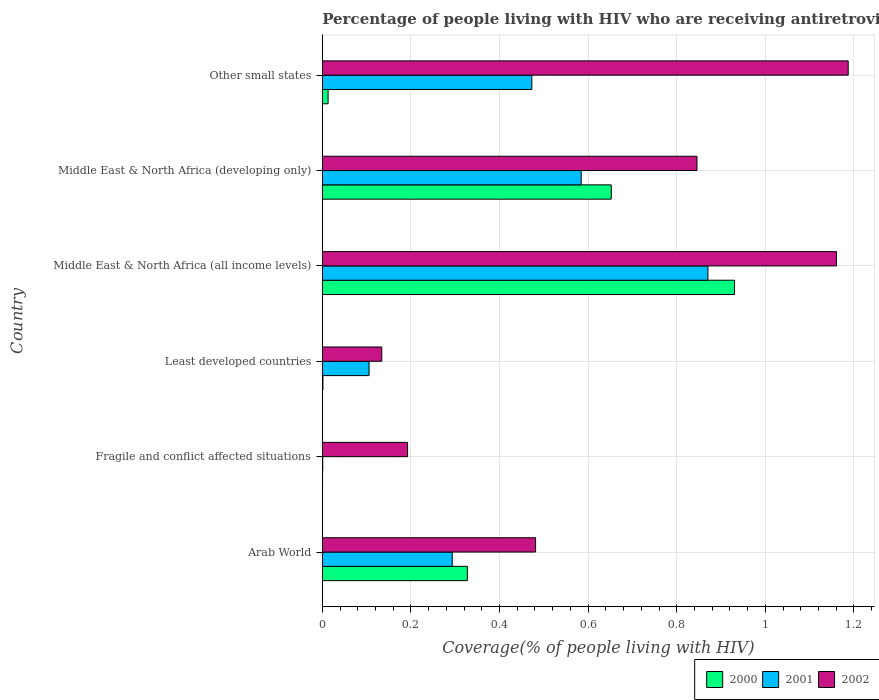How many different coloured bars are there?
Keep it short and to the point. 3. Are the number of bars per tick equal to the number of legend labels?
Your response must be concise. Yes. How many bars are there on the 1st tick from the top?
Keep it short and to the point. 3. What is the label of the 1st group of bars from the top?
Make the answer very short. Other small states. What is the percentage of the HIV infected people who are receiving antiretroviral therapy in 2000 in Middle East & North Africa (developing only)?
Your response must be concise. 0.65. Across all countries, what is the maximum percentage of the HIV infected people who are receiving antiretroviral therapy in 2001?
Provide a short and direct response. 0.87. Across all countries, what is the minimum percentage of the HIV infected people who are receiving antiretroviral therapy in 2002?
Your answer should be compact. 0.13. In which country was the percentage of the HIV infected people who are receiving antiretroviral therapy in 2002 maximum?
Provide a short and direct response. Other small states. In which country was the percentage of the HIV infected people who are receiving antiretroviral therapy in 2000 minimum?
Provide a succinct answer. Fragile and conflict affected situations. What is the total percentage of the HIV infected people who are receiving antiretroviral therapy in 2000 in the graph?
Your answer should be very brief. 1.92. What is the difference between the percentage of the HIV infected people who are receiving antiretroviral therapy in 2000 in Arab World and that in Other small states?
Give a very brief answer. 0.31. What is the difference between the percentage of the HIV infected people who are receiving antiretroviral therapy in 2001 in Fragile and conflict affected situations and the percentage of the HIV infected people who are receiving antiretroviral therapy in 2002 in Least developed countries?
Ensure brevity in your answer.  -0.13. What is the average percentage of the HIV infected people who are receiving antiretroviral therapy in 2002 per country?
Keep it short and to the point. 0.67. What is the difference between the percentage of the HIV infected people who are receiving antiretroviral therapy in 2001 and percentage of the HIV infected people who are receiving antiretroviral therapy in 2000 in Middle East & North Africa (developing only)?
Give a very brief answer. -0.07. In how many countries, is the percentage of the HIV infected people who are receiving antiretroviral therapy in 2000 greater than 0.12 %?
Offer a very short reply. 3. What is the ratio of the percentage of the HIV infected people who are receiving antiretroviral therapy in 2002 in Arab World to that in Middle East & North Africa (all income levels)?
Keep it short and to the point. 0.41. What is the difference between the highest and the second highest percentage of the HIV infected people who are receiving antiretroviral therapy in 2001?
Provide a succinct answer. 0.29. What is the difference between the highest and the lowest percentage of the HIV infected people who are receiving antiretroviral therapy in 2001?
Your answer should be compact. 0.87. Is the sum of the percentage of the HIV infected people who are receiving antiretroviral therapy in 2001 in Arab World and Other small states greater than the maximum percentage of the HIV infected people who are receiving antiretroviral therapy in 2002 across all countries?
Your response must be concise. No. What does the 2nd bar from the top in Fragile and conflict affected situations represents?
Make the answer very short. 2001. What does the 2nd bar from the bottom in Other small states represents?
Provide a succinct answer. 2001. How many bars are there?
Give a very brief answer. 18. Are all the bars in the graph horizontal?
Your answer should be very brief. Yes. How many countries are there in the graph?
Your response must be concise. 6. What is the difference between two consecutive major ticks on the X-axis?
Provide a short and direct response. 0.2. Are the values on the major ticks of X-axis written in scientific E-notation?
Your answer should be very brief. No. Does the graph contain any zero values?
Keep it short and to the point. No. Does the graph contain grids?
Your response must be concise. Yes. Where does the legend appear in the graph?
Ensure brevity in your answer.  Bottom right. What is the title of the graph?
Offer a very short reply. Percentage of people living with HIV who are receiving antiretroviral therapy. Does "1998" appear as one of the legend labels in the graph?
Ensure brevity in your answer.  No. What is the label or title of the X-axis?
Provide a short and direct response. Coverage(% of people living with HIV). What is the Coverage(% of people living with HIV) in 2000 in Arab World?
Ensure brevity in your answer.  0.33. What is the Coverage(% of people living with HIV) of 2001 in Arab World?
Your answer should be very brief. 0.29. What is the Coverage(% of people living with HIV) of 2002 in Arab World?
Make the answer very short. 0.48. What is the Coverage(% of people living with HIV) in 2000 in Fragile and conflict affected situations?
Offer a very short reply. 0. What is the Coverage(% of people living with HIV) in 2001 in Fragile and conflict affected situations?
Give a very brief answer. 0. What is the Coverage(% of people living with HIV) in 2002 in Fragile and conflict affected situations?
Provide a succinct answer. 0.19. What is the Coverage(% of people living with HIV) of 2000 in Least developed countries?
Ensure brevity in your answer.  0. What is the Coverage(% of people living with HIV) of 2001 in Least developed countries?
Provide a succinct answer. 0.11. What is the Coverage(% of people living with HIV) in 2002 in Least developed countries?
Offer a terse response. 0.13. What is the Coverage(% of people living with HIV) in 2000 in Middle East & North Africa (all income levels)?
Provide a short and direct response. 0.93. What is the Coverage(% of people living with HIV) of 2001 in Middle East & North Africa (all income levels)?
Your answer should be compact. 0.87. What is the Coverage(% of people living with HIV) of 2002 in Middle East & North Africa (all income levels)?
Offer a terse response. 1.16. What is the Coverage(% of people living with HIV) in 2000 in Middle East & North Africa (developing only)?
Provide a short and direct response. 0.65. What is the Coverage(% of people living with HIV) in 2001 in Middle East & North Africa (developing only)?
Offer a terse response. 0.58. What is the Coverage(% of people living with HIV) in 2002 in Middle East & North Africa (developing only)?
Your response must be concise. 0.85. What is the Coverage(% of people living with HIV) of 2000 in Other small states?
Your answer should be very brief. 0.01. What is the Coverage(% of people living with HIV) in 2001 in Other small states?
Give a very brief answer. 0.47. What is the Coverage(% of people living with HIV) in 2002 in Other small states?
Provide a short and direct response. 1.19. Across all countries, what is the maximum Coverage(% of people living with HIV) of 2000?
Give a very brief answer. 0.93. Across all countries, what is the maximum Coverage(% of people living with HIV) of 2001?
Make the answer very short. 0.87. Across all countries, what is the maximum Coverage(% of people living with HIV) in 2002?
Your answer should be very brief. 1.19. Across all countries, what is the minimum Coverage(% of people living with HIV) in 2000?
Provide a succinct answer. 0. Across all countries, what is the minimum Coverage(% of people living with HIV) of 2001?
Your response must be concise. 0. Across all countries, what is the minimum Coverage(% of people living with HIV) in 2002?
Provide a succinct answer. 0.13. What is the total Coverage(% of people living with HIV) in 2000 in the graph?
Your response must be concise. 1.92. What is the total Coverage(% of people living with HIV) in 2001 in the graph?
Keep it short and to the point. 2.33. What is the total Coverage(% of people living with HIV) of 2002 in the graph?
Keep it short and to the point. 4. What is the difference between the Coverage(% of people living with HIV) of 2000 in Arab World and that in Fragile and conflict affected situations?
Your answer should be compact. 0.33. What is the difference between the Coverage(% of people living with HIV) in 2001 in Arab World and that in Fragile and conflict affected situations?
Keep it short and to the point. 0.29. What is the difference between the Coverage(% of people living with HIV) of 2002 in Arab World and that in Fragile and conflict affected situations?
Your answer should be very brief. 0.29. What is the difference between the Coverage(% of people living with HIV) of 2000 in Arab World and that in Least developed countries?
Keep it short and to the point. 0.33. What is the difference between the Coverage(% of people living with HIV) of 2001 in Arab World and that in Least developed countries?
Ensure brevity in your answer.  0.19. What is the difference between the Coverage(% of people living with HIV) in 2002 in Arab World and that in Least developed countries?
Your answer should be compact. 0.35. What is the difference between the Coverage(% of people living with HIV) of 2000 in Arab World and that in Middle East & North Africa (all income levels)?
Provide a short and direct response. -0.6. What is the difference between the Coverage(% of people living with HIV) of 2001 in Arab World and that in Middle East & North Africa (all income levels)?
Your answer should be very brief. -0.58. What is the difference between the Coverage(% of people living with HIV) of 2002 in Arab World and that in Middle East & North Africa (all income levels)?
Provide a short and direct response. -0.68. What is the difference between the Coverage(% of people living with HIV) of 2000 in Arab World and that in Middle East & North Africa (developing only)?
Provide a succinct answer. -0.32. What is the difference between the Coverage(% of people living with HIV) in 2001 in Arab World and that in Middle East & North Africa (developing only)?
Offer a terse response. -0.29. What is the difference between the Coverage(% of people living with HIV) of 2002 in Arab World and that in Middle East & North Africa (developing only)?
Make the answer very short. -0.36. What is the difference between the Coverage(% of people living with HIV) in 2000 in Arab World and that in Other small states?
Offer a terse response. 0.31. What is the difference between the Coverage(% of people living with HIV) of 2001 in Arab World and that in Other small states?
Make the answer very short. -0.18. What is the difference between the Coverage(% of people living with HIV) of 2002 in Arab World and that in Other small states?
Provide a short and direct response. -0.71. What is the difference between the Coverage(% of people living with HIV) of 2000 in Fragile and conflict affected situations and that in Least developed countries?
Give a very brief answer. -0. What is the difference between the Coverage(% of people living with HIV) in 2001 in Fragile and conflict affected situations and that in Least developed countries?
Provide a short and direct response. -0.1. What is the difference between the Coverage(% of people living with HIV) in 2002 in Fragile and conflict affected situations and that in Least developed countries?
Offer a terse response. 0.06. What is the difference between the Coverage(% of people living with HIV) in 2000 in Fragile and conflict affected situations and that in Middle East & North Africa (all income levels)?
Offer a terse response. -0.93. What is the difference between the Coverage(% of people living with HIV) of 2001 in Fragile and conflict affected situations and that in Middle East & North Africa (all income levels)?
Offer a very short reply. -0.87. What is the difference between the Coverage(% of people living with HIV) in 2002 in Fragile and conflict affected situations and that in Middle East & North Africa (all income levels)?
Provide a succinct answer. -0.97. What is the difference between the Coverage(% of people living with HIV) of 2000 in Fragile and conflict affected situations and that in Middle East & North Africa (developing only)?
Provide a short and direct response. -0.65. What is the difference between the Coverage(% of people living with HIV) of 2001 in Fragile and conflict affected situations and that in Middle East & North Africa (developing only)?
Ensure brevity in your answer.  -0.58. What is the difference between the Coverage(% of people living with HIV) of 2002 in Fragile and conflict affected situations and that in Middle East & North Africa (developing only)?
Offer a terse response. -0.65. What is the difference between the Coverage(% of people living with HIV) in 2000 in Fragile and conflict affected situations and that in Other small states?
Give a very brief answer. -0.01. What is the difference between the Coverage(% of people living with HIV) of 2001 in Fragile and conflict affected situations and that in Other small states?
Your answer should be very brief. -0.47. What is the difference between the Coverage(% of people living with HIV) in 2002 in Fragile and conflict affected situations and that in Other small states?
Ensure brevity in your answer.  -0.99. What is the difference between the Coverage(% of people living with HIV) in 2000 in Least developed countries and that in Middle East & North Africa (all income levels)?
Make the answer very short. -0.93. What is the difference between the Coverage(% of people living with HIV) in 2001 in Least developed countries and that in Middle East & North Africa (all income levels)?
Offer a very short reply. -0.76. What is the difference between the Coverage(% of people living with HIV) in 2002 in Least developed countries and that in Middle East & North Africa (all income levels)?
Your answer should be very brief. -1.03. What is the difference between the Coverage(% of people living with HIV) in 2000 in Least developed countries and that in Middle East & North Africa (developing only)?
Offer a very short reply. -0.65. What is the difference between the Coverage(% of people living with HIV) in 2001 in Least developed countries and that in Middle East & North Africa (developing only)?
Ensure brevity in your answer.  -0.48. What is the difference between the Coverage(% of people living with HIV) of 2002 in Least developed countries and that in Middle East & North Africa (developing only)?
Give a very brief answer. -0.71. What is the difference between the Coverage(% of people living with HIV) of 2000 in Least developed countries and that in Other small states?
Your response must be concise. -0.01. What is the difference between the Coverage(% of people living with HIV) in 2001 in Least developed countries and that in Other small states?
Offer a very short reply. -0.37. What is the difference between the Coverage(% of people living with HIV) of 2002 in Least developed countries and that in Other small states?
Offer a very short reply. -1.05. What is the difference between the Coverage(% of people living with HIV) in 2000 in Middle East & North Africa (all income levels) and that in Middle East & North Africa (developing only)?
Keep it short and to the point. 0.28. What is the difference between the Coverage(% of people living with HIV) in 2001 in Middle East & North Africa (all income levels) and that in Middle East & North Africa (developing only)?
Your response must be concise. 0.29. What is the difference between the Coverage(% of people living with HIV) of 2002 in Middle East & North Africa (all income levels) and that in Middle East & North Africa (developing only)?
Offer a terse response. 0.31. What is the difference between the Coverage(% of people living with HIV) in 2000 in Middle East & North Africa (all income levels) and that in Other small states?
Your answer should be very brief. 0.92. What is the difference between the Coverage(% of people living with HIV) in 2001 in Middle East & North Africa (all income levels) and that in Other small states?
Provide a succinct answer. 0.4. What is the difference between the Coverage(% of people living with HIV) of 2002 in Middle East & North Africa (all income levels) and that in Other small states?
Offer a very short reply. -0.03. What is the difference between the Coverage(% of people living with HIV) in 2000 in Middle East & North Africa (developing only) and that in Other small states?
Offer a very short reply. 0.64. What is the difference between the Coverage(% of people living with HIV) of 2001 in Middle East & North Africa (developing only) and that in Other small states?
Ensure brevity in your answer.  0.11. What is the difference between the Coverage(% of people living with HIV) of 2002 in Middle East & North Africa (developing only) and that in Other small states?
Your answer should be compact. -0.34. What is the difference between the Coverage(% of people living with HIV) in 2000 in Arab World and the Coverage(% of people living with HIV) in 2001 in Fragile and conflict affected situations?
Ensure brevity in your answer.  0.33. What is the difference between the Coverage(% of people living with HIV) of 2000 in Arab World and the Coverage(% of people living with HIV) of 2002 in Fragile and conflict affected situations?
Make the answer very short. 0.13. What is the difference between the Coverage(% of people living with HIV) of 2001 in Arab World and the Coverage(% of people living with HIV) of 2002 in Fragile and conflict affected situations?
Provide a succinct answer. 0.1. What is the difference between the Coverage(% of people living with HIV) of 2000 in Arab World and the Coverage(% of people living with HIV) of 2001 in Least developed countries?
Offer a terse response. 0.22. What is the difference between the Coverage(% of people living with HIV) in 2000 in Arab World and the Coverage(% of people living with HIV) in 2002 in Least developed countries?
Provide a succinct answer. 0.19. What is the difference between the Coverage(% of people living with HIV) in 2001 in Arab World and the Coverage(% of people living with HIV) in 2002 in Least developed countries?
Offer a very short reply. 0.16. What is the difference between the Coverage(% of people living with HIV) of 2000 in Arab World and the Coverage(% of people living with HIV) of 2001 in Middle East & North Africa (all income levels)?
Make the answer very short. -0.54. What is the difference between the Coverage(% of people living with HIV) of 2000 in Arab World and the Coverage(% of people living with HIV) of 2002 in Middle East & North Africa (all income levels)?
Offer a terse response. -0.83. What is the difference between the Coverage(% of people living with HIV) of 2001 in Arab World and the Coverage(% of people living with HIV) of 2002 in Middle East & North Africa (all income levels)?
Offer a terse response. -0.87. What is the difference between the Coverage(% of people living with HIV) of 2000 in Arab World and the Coverage(% of people living with HIV) of 2001 in Middle East & North Africa (developing only)?
Make the answer very short. -0.26. What is the difference between the Coverage(% of people living with HIV) in 2000 in Arab World and the Coverage(% of people living with HIV) in 2002 in Middle East & North Africa (developing only)?
Your answer should be very brief. -0.52. What is the difference between the Coverage(% of people living with HIV) of 2001 in Arab World and the Coverage(% of people living with HIV) of 2002 in Middle East & North Africa (developing only)?
Your answer should be very brief. -0.55. What is the difference between the Coverage(% of people living with HIV) of 2000 in Arab World and the Coverage(% of people living with HIV) of 2001 in Other small states?
Ensure brevity in your answer.  -0.15. What is the difference between the Coverage(% of people living with HIV) in 2000 in Arab World and the Coverage(% of people living with HIV) in 2002 in Other small states?
Offer a very short reply. -0.86. What is the difference between the Coverage(% of people living with HIV) in 2001 in Arab World and the Coverage(% of people living with HIV) in 2002 in Other small states?
Keep it short and to the point. -0.89. What is the difference between the Coverage(% of people living with HIV) in 2000 in Fragile and conflict affected situations and the Coverage(% of people living with HIV) in 2001 in Least developed countries?
Your answer should be very brief. -0.1. What is the difference between the Coverage(% of people living with HIV) of 2000 in Fragile and conflict affected situations and the Coverage(% of people living with HIV) of 2002 in Least developed countries?
Your answer should be very brief. -0.13. What is the difference between the Coverage(% of people living with HIV) in 2001 in Fragile and conflict affected situations and the Coverage(% of people living with HIV) in 2002 in Least developed countries?
Provide a succinct answer. -0.13. What is the difference between the Coverage(% of people living with HIV) of 2000 in Fragile and conflict affected situations and the Coverage(% of people living with HIV) of 2001 in Middle East & North Africa (all income levels)?
Your response must be concise. -0.87. What is the difference between the Coverage(% of people living with HIV) in 2000 in Fragile and conflict affected situations and the Coverage(% of people living with HIV) in 2002 in Middle East & North Africa (all income levels)?
Provide a short and direct response. -1.16. What is the difference between the Coverage(% of people living with HIV) of 2001 in Fragile and conflict affected situations and the Coverage(% of people living with HIV) of 2002 in Middle East & North Africa (all income levels)?
Your answer should be compact. -1.16. What is the difference between the Coverage(% of people living with HIV) of 2000 in Fragile and conflict affected situations and the Coverage(% of people living with HIV) of 2001 in Middle East & North Africa (developing only)?
Your answer should be very brief. -0.58. What is the difference between the Coverage(% of people living with HIV) in 2000 in Fragile and conflict affected situations and the Coverage(% of people living with HIV) in 2002 in Middle East & North Africa (developing only)?
Offer a very short reply. -0.85. What is the difference between the Coverage(% of people living with HIV) in 2001 in Fragile and conflict affected situations and the Coverage(% of people living with HIV) in 2002 in Middle East & North Africa (developing only)?
Provide a short and direct response. -0.84. What is the difference between the Coverage(% of people living with HIV) of 2000 in Fragile and conflict affected situations and the Coverage(% of people living with HIV) of 2001 in Other small states?
Offer a very short reply. -0.47. What is the difference between the Coverage(% of people living with HIV) of 2000 in Fragile and conflict affected situations and the Coverage(% of people living with HIV) of 2002 in Other small states?
Your answer should be very brief. -1.19. What is the difference between the Coverage(% of people living with HIV) in 2001 in Fragile and conflict affected situations and the Coverage(% of people living with HIV) in 2002 in Other small states?
Offer a very short reply. -1.19. What is the difference between the Coverage(% of people living with HIV) of 2000 in Least developed countries and the Coverage(% of people living with HIV) of 2001 in Middle East & North Africa (all income levels)?
Offer a very short reply. -0.87. What is the difference between the Coverage(% of people living with HIV) of 2000 in Least developed countries and the Coverage(% of people living with HIV) of 2002 in Middle East & North Africa (all income levels)?
Ensure brevity in your answer.  -1.16. What is the difference between the Coverage(% of people living with HIV) of 2001 in Least developed countries and the Coverage(% of people living with HIV) of 2002 in Middle East & North Africa (all income levels)?
Your response must be concise. -1.05. What is the difference between the Coverage(% of people living with HIV) of 2000 in Least developed countries and the Coverage(% of people living with HIV) of 2001 in Middle East & North Africa (developing only)?
Ensure brevity in your answer.  -0.58. What is the difference between the Coverage(% of people living with HIV) in 2000 in Least developed countries and the Coverage(% of people living with HIV) in 2002 in Middle East & North Africa (developing only)?
Your response must be concise. -0.84. What is the difference between the Coverage(% of people living with HIV) of 2001 in Least developed countries and the Coverage(% of people living with HIV) of 2002 in Middle East & North Africa (developing only)?
Your answer should be compact. -0.74. What is the difference between the Coverage(% of people living with HIV) in 2000 in Least developed countries and the Coverage(% of people living with HIV) in 2001 in Other small states?
Ensure brevity in your answer.  -0.47. What is the difference between the Coverage(% of people living with HIV) of 2000 in Least developed countries and the Coverage(% of people living with HIV) of 2002 in Other small states?
Provide a short and direct response. -1.19. What is the difference between the Coverage(% of people living with HIV) in 2001 in Least developed countries and the Coverage(% of people living with HIV) in 2002 in Other small states?
Keep it short and to the point. -1.08. What is the difference between the Coverage(% of people living with HIV) of 2000 in Middle East & North Africa (all income levels) and the Coverage(% of people living with HIV) of 2001 in Middle East & North Africa (developing only)?
Keep it short and to the point. 0.35. What is the difference between the Coverage(% of people living with HIV) in 2000 in Middle East & North Africa (all income levels) and the Coverage(% of people living with HIV) in 2002 in Middle East & North Africa (developing only)?
Give a very brief answer. 0.08. What is the difference between the Coverage(% of people living with HIV) in 2001 in Middle East & North Africa (all income levels) and the Coverage(% of people living with HIV) in 2002 in Middle East & North Africa (developing only)?
Offer a terse response. 0.02. What is the difference between the Coverage(% of people living with HIV) of 2000 in Middle East & North Africa (all income levels) and the Coverage(% of people living with HIV) of 2001 in Other small states?
Offer a terse response. 0.46. What is the difference between the Coverage(% of people living with HIV) in 2000 in Middle East & North Africa (all income levels) and the Coverage(% of people living with HIV) in 2002 in Other small states?
Provide a succinct answer. -0.26. What is the difference between the Coverage(% of people living with HIV) of 2001 in Middle East & North Africa (all income levels) and the Coverage(% of people living with HIV) of 2002 in Other small states?
Provide a succinct answer. -0.32. What is the difference between the Coverage(% of people living with HIV) of 2000 in Middle East & North Africa (developing only) and the Coverage(% of people living with HIV) of 2001 in Other small states?
Your answer should be very brief. 0.18. What is the difference between the Coverage(% of people living with HIV) of 2000 in Middle East & North Africa (developing only) and the Coverage(% of people living with HIV) of 2002 in Other small states?
Give a very brief answer. -0.53. What is the difference between the Coverage(% of people living with HIV) of 2001 in Middle East & North Africa (developing only) and the Coverage(% of people living with HIV) of 2002 in Other small states?
Your response must be concise. -0.6. What is the average Coverage(% of people living with HIV) in 2000 per country?
Your answer should be very brief. 0.32. What is the average Coverage(% of people living with HIV) of 2001 per country?
Offer a terse response. 0.39. What is the average Coverage(% of people living with HIV) in 2002 per country?
Your answer should be very brief. 0.67. What is the difference between the Coverage(% of people living with HIV) in 2000 and Coverage(% of people living with HIV) in 2001 in Arab World?
Offer a very short reply. 0.03. What is the difference between the Coverage(% of people living with HIV) of 2000 and Coverage(% of people living with HIV) of 2002 in Arab World?
Your response must be concise. -0.15. What is the difference between the Coverage(% of people living with HIV) in 2001 and Coverage(% of people living with HIV) in 2002 in Arab World?
Ensure brevity in your answer.  -0.19. What is the difference between the Coverage(% of people living with HIV) of 2000 and Coverage(% of people living with HIV) of 2001 in Fragile and conflict affected situations?
Your answer should be very brief. -0. What is the difference between the Coverage(% of people living with HIV) in 2000 and Coverage(% of people living with HIV) in 2002 in Fragile and conflict affected situations?
Make the answer very short. -0.19. What is the difference between the Coverage(% of people living with HIV) in 2001 and Coverage(% of people living with HIV) in 2002 in Fragile and conflict affected situations?
Your answer should be compact. -0.19. What is the difference between the Coverage(% of people living with HIV) in 2000 and Coverage(% of people living with HIV) in 2001 in Least developed countries?
Ensure brevity in your answer.  -0.1. What is the difference between the Coverage(% of people living with HIV) in 2000 and Coverage(% of people living with HIV) in 2002 in Least developed countries?
Provide a succinct answer. -0.13. What is the difference between the Coverage(% of people living with HIV) in 2001 and Coverage(% of people living with HIV) in 2002 in Least developed countries?
Keep it short and to the point. -0.03. What is the difference between the Coverage(% of people living with HIV) in 2000 and Coverage(% of people living with HIV) in 2001 in Middle East & North Africa (all income levels)?
Provide a succinct answer. 0.06. What is the difference between the Coverage(% of people living with HIV) of 2000 and Coverage(% of people living with HIV) of 2002 in Middle East & North Africa (all income levels)?
Your response must be concise. -0.23. What is the difference between the Coverage(% of people living with HIV) in 2001 and Coverage(% of people living with HIV) in 2002 in Middle East & North Africa (all income levels)?
Your answer should be compact. -0.29. What is the difference between the Coverage(% of people living with HIV) of 2000 and Coverage(% of people living with HIV) of 2001 in Middle East & North Africa (developing only)?
Your answer should be compact. 0.07. What is the difference between the Coverage(% of people living with HIV) of 2000 and Coverage(% of people living with HIV) of 2002 in Middle East & North Africa (developing only)?
Give a very brief answer. -0.19. What is the difference between the Coverage(% of people living with HIV) in 2001 and Coverage(% of people living with HIV) in 2002 in Middle East & North Africa (developing only)?
Keep it short and to the point. -0.26. What is the difference between the Coverage(% of people living with HIV) in 2000 and Coverage(% of people living with HIV) in 2001 in Other small states?
Provide a succinct answer. -0.46. What is the difference between the Coverage(% of people living with HIV) of 2000 and Coverage(% of people living with HIV) of 2002 in Other small states?
Your answer should be very brief. -1.17. What is the difference between the Coverage(% of people living with HIV) in 2001 and Coverage(% of people living with HIV) in 2002 in Other small states?
Make the answer very short. -0.71. What is the ratio of the Coverage(% of people living with HIV) in 2000 in Arab World to that in Fragile and conflict affected situations?
Provide a succinct answer. 679.72. What is the ratio of the Coverage(% of people living with HIV) of 2001 in Arab World to that in Fragile and conflict affected situations?
Make the answer very short. 310.29. What is the ratio of the Coverage(% of people living with HIV) of 2002 in Arab World to that in Fragile and conflict affected situations?
Offer a very short reply. 2.5. What is the ratio of the Coverage(% of people living with HIV) of 2000 in Arab World to that in Least developed countries?
Provide a short and direct response. 245.99. What is the ratio of the Coverage(% of people living with HIV) of 2001 in Arab World to that in Least developed countries?
Make the answer very short. 2.78. What is the ratio of the Coverage(% of people living with HIV) in 2002 in Arab World to that in Least developed countries?
Give a very brief answer. 3.59. What is the ratio of the Coverage(% of people living with HIV) in 2000 in Arab World to that in Middle East & North Africa (all income levels)?
Your response must be concise. 0.35. What is the ratio of the Coverage(% of people living with HIV) of 2001 in Arab World to that in Middle East & North Africa (all income levels)?
Offer a terse response. 0.34. What is the ratio of the Coverage(% of people living with HIV) in 2002 in Arab World to that in Middle East & North Africa (all income levels)?
Your answer should be compact. 0.41. What is the ratio of the Coverage(% of people living with HIV) in 2000 in Arab World to that in Middle East & North Africa (developing only)?
Offer a terse response. 0.5. What is the ratio of the Coverage(% of people living with HIV) in 2001 in Arab World to that in Middle East & North Africa (developing only)?
Offer a terse response. 0.5. What is the ratio of the Coverage(% of people living with HIV) in 2002 in Arab World to that in Middle East & North Africa (developing only)?
Your response must be concise. 0.57. What is the ratio of the Coverage(% of people living with HIV) of 2000 in Arab World to that in Other small states?
Your response must be concise. 25.16. What is the ratio of the Coverage(% of people living with HIV) in 2001 in Arab World to that in Other small states?
Your answer should be very brief. 0.62. What is the ratio of the Coverage(% of people living with HIV) in 2002 in Arab World to that in Other small states?
Keep it short and to the point. 0.41. What is the ratio of the Coverage(% of people living with HIV) in 2000 in Fragile and conflict affected situations to that in Least developed countries?
Your answer should be compact. 0.36. What is the ratio of the Coverage(% of people living with HIV) in 2001 in Fragile and conflict affected situations to that in Least developed countries?
Provide a succinct answer. 0.01. What is the ratio of the Coverage(% of people living with HIV) in 2002 in Fragile and conflict affected situations to that in Least developed countries?
Your answer should be very brief. 1.43. What is the ratio of the Coverage(% of people living with HIV) of 2001 in Fragile and conflict affected situations to that in Middle East & North Africa (all income levels)?
Offer a very short reply. 0. What is the ratio of the Coverage(% of people living with HIV) of 2002 in Fragile and conflict affected situations to that in Middle East & North Africa (all income levels)?
Make the answer very short. 0.17. What is the ratio of the Coverage(% of people living with HIV) of 2000 in Fragile and conflict affected situations to that in Middle East & North Africa (developing only)?
Your answer should be compact. 0. What is the ratio of the Coverage(% of people living with HIV) in 2001 in Fragile and conflict affected situations to that in Middle East & North Africa (developing only)?
Offer a very short reply. 0. What is the ratio of the Coverage(% of people living with HIV) of 2002 in Fragile and conflict affected situations to that in Middle East & North Africa (developing only)?
Give a very brief answer. 0.23. What is the ratio of the Coverage(% of people living with HIV) of 2000 in Fragile and conflict affected situations to that in Other small states?
Provide a short and direct response. 0.04. What is the ratio of the Coverage(% of people living with HIV) of 2001 in Fragile and conflict affected situations to that in Other small states?
Provide a short and direct response. 0. What is the ratio of the Coverage(% of people living with HIV) of 2002 in Fragile and conflict affected situations to that in Other small states?
Give a very brief answer. 0.16. What is the ratio of the Coverage(% of people living with HIV) of 2000 in Least developed countries to that in Middle East & North Africa (all income levels)?
Offer a very short reply. 0. What is the ratio of the Coverage(% of people living with HIV) of 2001 in Least developed countries to that in Middle East & North Africa (all income levels)?
Offer a very short reply. 0.12. What is the ratio of the Coverage(% of people living with HIV) of 2002 in Least developed countries to that in Middle East & North Africa (all income levels)?
Provide a short and direct response. 0.12. What is the ratio of the Coverage(% of people living with HIV) in 2000 in Least developed countries to that in Middle East & North Africa (developing only)?
Keep it short and to the point. 0. What is the ratio of the Coverage(% of people living with HIV) in 2001 in Least developed countries to that in Middle East & North Africa (developing only)?
Provide a short and direct response. 0.18. What is the ratio of the Coverage(% of people living with HIV) in 2002 in Least developed countries to that in Middle East & North Africa (developing only)?
Make the answer very short. 0.16. What is the ratio of the Coverage(% of people living with HIV) in 2000 in Least developed countries to that in Other small states?
Provide a short and direct response. 0.1. What is the ratio of the Coverage(% of people living with HIV) in 2001 in Least developed countries to that in Other small states?
Provide a succinct answer. 0.22. What is the ratio of the Coverage(% of people living with HIV) in 2002 in Least developed countries to that in Other small states?
Ensure brevity in your answer.  0.11. What is the ratio of the Coverage(% of people living with HIV) of 2000 in Middle East & North Africa (all income levels) to that in Middle East & North Africa (developing only)?
Offer a very short reply. 1.43. What is the ratio of the Coverage(% of people living with HIV) of 2001 in Middle East & North Africa (all income levels) to that in Middle East & North Africa (developing only)?
Your response must be concise. 1.49. What is the ratio of the Coverage(% of people living with HIV) of 2002 in Middle East & North Africa (all income levels) to that in Middle East & North Africa (developing only)?
Offer a terse response. 1.37. What is the ratio of the Coverage(% of people living with HIV) of 2000 in Middle East & North Africa (all income levels) to that in Other small states?
Offer a terse response. 71.51. What is the ratio of the Coverage(% of people living with HIV) in 2001 in Middle East & North Africa (all income levels) to that in Other small states?
Your answer should be compact. 1.84. What is the ratio of the Coverage(% of people living with HIV) of 2002 in Middle East & North Africa (all income levels) to that in Other small states?
Give a very brief answer. 0.98. What is the ratio of the Coverage(% of people living with HIV) in 2000 in Middle East & North Africa (developing only) to that in Other small states?
Offer a very short reply. 50.14. What is the ratio of the Coverage(% of people living with HIV) of 2001 in Middle East & North Africa (developing only) to that in Other small states?
Your answer should be compact. 1.24. What is the ratio of the Coverage(% of people living with HIV) in 2002 in Middle East & North Africa (developing only) to that in Other small states?
Your answer should be very brief. 0.71. What is the difference between the highest and the second highest Coverage(% of people living with HIV) of 2000?
Give a very brief answer. 0.28. What is the difference between the highest and the second highest Coverage(% of people living with HIV) in 2001?
Give a very brief answer. 0.29. What is the difference between the highest and the second highest Coverage(% of people living with HIV) of 2002?
Offer a terse response. 0.03. What is the difference between the highest and the lowest Coverage(% of people living with HIV) in 2000?
Your answer should be compact. 0.93. What is the difference between the highest and the lowest Coverage(% of people living with HIV) in 2001?
Provide a succinct answer. 0.87. What is the difference between the highest and the lowest Coverage(% of people living with HIV) in 2002?
Offer a very short reply. 1.05. 